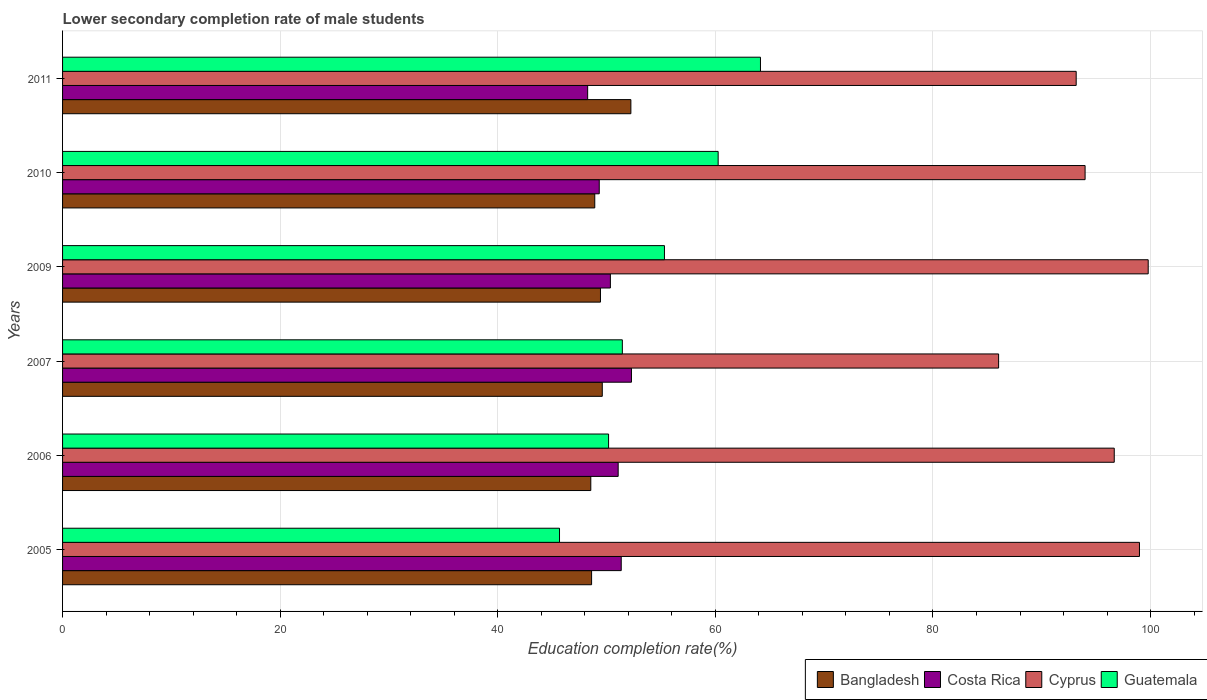How many groups of bars are there?
Your answer should be compact. 6. Are the number of bars on each tick of the Y-axis equal?
Your answer should be very brief. Yes. How many bars are there on the 5th tick from the bottom?
Your response must be concise. 4. What is the lower secondary completion rate of male students in Costa Rica in 2011?
Keep it short and to the point. 48.26. Across all years, what is the maximum lower secondary completion rate of male students in Costa Rica?
Ensure brevity in your answer.  52.29. Across all years, what is the minimum lower secondary completion rate of male students in Costa Rica?
Give a very brief answer. 48.26. What is the total lower secondary completion rate of male students in Cyprus in the graph?
Your answer should be compact. 568.61. What is the difference between the lower secondary completion rate of male students in Cyprus in 2006 and that in 2010?
Provide a succinct answer. 2.68. What is the difference between the lower secondary completion rate of male students in Costa Rica in 2010 and the lower secondary completion rate of male students in Guatemala in 2011?
Provide a short and direct response. -14.82. What is the average lower secondary completion rate of male students in Bangladesh per year?
Offer a very short reply. 49.56. In the year 2010, what is the difference between the lower secondary completion rate of male students in Guatemala and lower secondary completion rate of male students in Bangladesh?
Ensure brevity in your answer.  11.34. In how many years, is the lower secondary completion rate of male students in Guatemala greater than 24 %?
Provide a short and direct response. 6. What is the ratio of the lower secondary completion rate of male students in Costa Rica in 2005 to that in 2011?
Your answer should be compact. 1.06. What is the difference between the highest and the second highest lower secondary completion rate of male students in Cyprus?
Offer a very short reply. 0.8. What is the difference between the highest and the lowest lower secondary completion rate of male students in Guatemala?
Provide a succinct answer. 18.47. Is it the case that in every year, the sum of the lower secondary completion rate of male students in Bangladesh and lower secondary completion rate of male students in Guatemala is greater than the sum of lower secondary completion rate of male students in Costa Rica and lower secondary completion rate of male students in Cyprus?
Your answer should be very brief. No. What does the 1st bar from the top in 2007 represents?
Give a very brief answer. Guatemala. What does the 4th bar from the bottom in 2005 represents?
Provide a succinct answer. Guatemala. Is it the case that in every year, the sum of the lower secondary completion rate of male students in Cyprus and lower secondary completion rate of male students in Costa Rica is greater than the lower secondary completion rate of male students in Bangladesh?
Keep it short and to the point. Yes. Are all the bars in the graph horizontal?
Provide a short and direct response. Yes. How many years are there in the graph?
Offer a very short reply. 6. What is the difference between two consecutive major ticks on the X-axis?
Give a very brief answer. 20. Are the values on the major ticks of X-axis written in scientific E-notation?
Keep it short and to the point. No. Where does the legend appear in the graph?
Your answer should be very brief. Bottom right. How are the legend labels stacked?
Offer a very short reply. Horizontal. What is the title of the graph?
Keep it short and to the point. Lower secondary completion rate of male students. What is the label or title of the X-axis?
Offer a terse response. Education completion rate(%). What is the label or title of the Y-axis?
Keep it short and to the point. Years. What is the Education completion rate(%) of Bangladesh in 2005?
Keep it short and to the point. 48.62. What is the Education completion rate(%) in Costa Rica in 2005?
Keep it short and to the point. 51.35. What is the Education completion rate(%) of Cyprus in 2005?
Provide a succinct answer. 98.98. What is the Education completion rate(%) of Guatemala in 2005?
Make the answer very short. 45.68. What is the Education completion rate(%) of Bangladesh in 2006?
Your answer should be very brief. 48.55. What is the Education completion rate(%) of Costa Rica in 2006?
Your answer should be compact. 51.07. What is the Education completion rate(%) of Cyprus in 2006?
Your answer should be very brief. 96.66. What is the Education completion rate(%) in Guatemala in 2006?
Give a very brief answer. 50.18. What is the Education completion rate(%) of Bangladesh in 2007?
Provide a succinct answer. 49.61. What is the Education completion rate(%) of Costa Rica in 2007?
Your answer should be compact. 52.29. What is the Education completion rate(%) of Cyprus in 2007?
Your answer should be compact. 86.03. What is the Education completion rate(%) of Guatemala in 2007?
Make the answer very short. 51.45. What is the Education completion rate(%) of Bangladesh in 2009?
Your answer should be very brief. 49.44. What is the Education completion rate(%) in Costa Rica in 2009?
Ensure brevity in your answer.  50.35. What is the Education completion rate(%) in Cyprus in 2009?
Make the answer very short. 99.78. What is the Education completion rate(%) of Guatemala in 2009?
Your response must be concise. 55.32. What is the Education completion rate(%) in Bangladesh in 2010?
Provide a short and direct response. 48.92. What is the Education completion rate(%) of Costa Rica in 2010?
Provide a short and direct response. 49.33. What is the Education completion rate(%) in Cyprus in 2010?
Your answer should be very brief. 93.98. What is the Education completion rate(%) in Guatemala in 2010?
Offer a terse response. 60.26. What is the Education completion rate(%) of Bangladesh in 2011?
Offer a terse response. 52.23. What is the Education completion rate(%) in Costa Rica in 2011?
Ensure brevity in your answer.  48.26. What is the Education completion rate(%) of Cyprus in 2011?
Offer a very short reply. 93.16. What is the Education completion rate(%) in Guatemala in 2011?
Ensure brevity in your answer.  64.15. Across all years, what is the maximum Education completion rate(%) in Bangladesh?
Provide a succinct answer. 52.23. Across all years, what is the maximum Education completion rate(%) of Costa Rica?
Your answer should be very brief. 52.29. Across all years, what is the maximum Education completion rate(%) of Cyprus?
Make the answer very short. 99.78. Across all years, what is the maximum Education completion rate(%) of Guatemala?
Give a very brief answer. 64.15. Across all years, what is the minimum Education completion rate(%) of Bangladesh?
Provide a short and direct response. 48.55. Across all years, what is the minimum Education completion rate(%) of Costa Rica?
Keep it short and to the point. 48.26. Across all years, what is the minimum Education completion rate(%) in Cyprus?
Ensure brevity in your answer.  86.03. Across all years, what is the minimum Education completion rate(%) of Guatemala?
Give a very brief answer. 45.68. What is the total Education completion rate(%) of Bangladesh in the graph?
Your answer should be compact. 297.37. What is the total Education completion rate(%) of Costa Rica in the graph?
Offer a very short reply. 302.64. What is the total Education completion rate(%) of Cyprus in the graph?
Keep it short and to the point. 568.61. What is the total Education completion rate(%) in Guatemala in the graph?
Your answer should be compact. 327.03. What is the difference between the Education completion rate(%) in Bangladesh in 2005 and that in 2006?
Provide a succinct answer. 0.07. What is the difference between the Education completion rate(%) in Costa Rica in 2005 and that in 2006?
Ensure brevity in your answer.  0.28. What is the difference between the Education completion rate(%) in Cyprus in 2005 and that in 2006?
Your answer should be compact. 2.32. What is the difference between the Education completion rate(%) of Guatemala in 2005 and that in 2006?
Offer a terse response. -4.51. What is the difference between the Education completion rate(%) in Bangladesh in 2005 and that in 2007?
Provide a short and direct response. -0.98. What is the difference between the Education completion rate(%) in Costa Rica in 2005 and that in 2007?
Offer a very short reply. -0.94. What is the difference between the Education completion rate(%) of Cyprus in 2005 and that in 2007?
Keep it short and to the point. 12.95. What is the difference between the Education completion rate(%) of Guatemala in 2005 and that in 2007?
Offer a very short reply. -5.77. What is the difference between the Education completion rate(%) of Bangladesh in 2005 and that in 2009?
Offer a very short reply. -0.82. What is the difference between the Education completion rate(%) in Cyprus in 2005 and that in 2009?
Your answer should be very brief. -0.8. What is the difference between the Education completion rate(%) of Guatemala in 2005 and that in 2009?
Your response must be concise. -9.64. What is the difference between the Education completion rate(%) of Bangladesh in 2005 and that in 2010?
Your answer should be very brief. -0.29. What is the difference between the Education completion rate(%) of Costa Rica in 2005 and that in 2010?
Give a very brief answer. 2.02. What is the difference between the Education completion rate(%) of Cyprus in 2005 and that in 2010?
Give a very brief answer. 5. What is the difference between the Education completion rate(%) of Guatemala in 2005 and that in 2010?
Keep it short and to the point. -14.58. What is the difference between the Education completion rate(%) in Bangladesh in 2005 and that in 2011?
Give a very brief answer. -3.61. What is the difference between the Education completion rate(%) of Costa Rica in 2005 and that in 2011?
Offer a terse response. 3.09. What is the difference between the Education completion rate(%) in Cyprus in 2005 and that in 2011?
Your answer should be very brief. 5.82. What is the difference between the Education completion rate(%) of Guatemala in 2005 and that in 2011?
Your answer should be very brief. -18.47. What is the difference between the Education completion rate(%) in Bangladesh in 2006 and that in 2007?
Provide a short and direct response. -1.06. What is the difference between the Education completion rate(%) of Costa Rica in 2006 and that in 2007?
Your response must be concise. -1.22. What is the difference between the Education completion rate(%) in Cyprus in 2006 and that in 2007?
Provide a short and direct response. 10.63. What is the difference between the Education completion rate(%) of Guatemala in 2006 and that in 2007?
Your answer should be compact. -1.26. What is the difference between the Education completion rate(%) of Bangladesh in 2006 and that in 2009?
Your answer should be compact. -0.89. What is the difference between the Education completion rate(%) in Costa Rica in 2006 and that in 2009?
Give a very brief answer. 0.71. What is the difference between the Education completion rate(%) in Cyprus in 2006 and that in 2009?
Offer a terse response. -3.12. What is the difference between the Education completion rate(%) of Guatemala in 2006 and that in 2009?
Your answer should be compact. -5.14. What is the difference between the Education completion rate(%) of Bangladesh in 2006 and that in 2010?
Offer a very short reply. -0.36. What is the difference between the Education completion rate(%) of Costa Rica in 2006 and that in 2010?
Keep it short and to the point. 1.74. What is the difference between the Education completion rate(%) of Cyprus in 2006 and that in 2010?
Your answer should be compact. 2.68. What is the difference between the Education completion rate(%) in Guatemala in 2006 and that in 2010?
Make the answer very short. -10.07. What is the difference between the Education completion rate(%) in Bangladesh in 2006 and that in 2011?
Ensure brevity in your answer.  -3.68. What is the difference between the Education completion rate(%) of Costa Rica in 2006 and that in 2011?
Provide a short and direct response. 2.8. What is the difference between the Education completion rate(%) in Cyprus in 2006 and that in 2011?
Your answer should be very brief. 3.5. What is the difference between the Education completion rate(%) of Guatemala in 2006 and that in 2011?
Keep it short and to the point. -13.96. What is the difference between the Education completion rate(%) of Bangladesh in 2007 and that in 2009?
Your answer should be very brief. 0.17. What is the difference between the Education completion rate(%) in Costa Rica in 2007 and that in 2009?
Your response must be concise. 1.94. What is the difference between the Education completion rate(%) in Cyprus in 2007 and that in 2009?
Give a very brief answer. -13.75. What is the difference between the Education completion rate(%) of Guatemala in 2007 and that in 2009?
Your response must be concise. -3.87. What is the difference between the Education completion rate(%) in Bangladesh in 2007 and that in 2010?
Your answer should be compact. 0.69. What is the difference between the Education completion rate(%) of Costa Rica in 2007 and that in 2010?
Provide a succinct answer. 2.96. What is the difference between the Education completion rate(%) in Cyprus in 2007 and that in 2010?
Keep it short and to the point. -7.95. What is the difference between the Education completion rate(%) of Guatemala in 2007 and that in 2010?
Your response must be concise. -8.81. What is the difference between the Education completion rate(%) of Bangladesh in 2007 and that in 2011?
Keep it short and to the point. -2.63. What is the difference between the Education completion rate(%) in Costa Rica in 2007 and that in 2011?
Make the answer very short. 4.03. What is the difference between the Education completion rate(%) in Cyprus in 2007 and that in 2011?
Offer a terse response. -7.13. What is the difference between the Education completion rate(%) in Guatemala in 2007 and that in 2011?
Make the answer very short. -12.7. What is the difference between the Education completion rate(%) in Bangladesh in 2009 and that in 2010?
Give a very brief answer. 0.52. What is the difference between the Education completion rate(%) of Costa Rica in 2009 and that in 2010?
Your answer should be very brief. 1.02. What is the difference between the Education completion rate(%) in Cyprus in 2009 and that in 2010?
Make the answer very short. 5.8. What is the difference between the Education completion rate(%) of Guatemala in 2009 and that in 2010?
Your response must be concise. -4.94. What is the difference between the Education completion rate(%) in Bangladesh in 2009 and that in 2011?
Make the answer very short. -2.8. What is the difference between the Education completion rate(%) of Costa Rica in 2009 and that in 2011?
Provide a succinct answer. 2.09. What is the difference between the Education completion rate(%) in Cyprus in 2009 and that in 2011?
Provide a succinct answer. 6.62. What is the difference between the Education completion rate(%) in Guatemala in 2009 and that in 2011?
Your answer should be compact. -8.82. What is the difference between the Education completion rate(%) in Bangladesh in 2010 and that in 2011?
Keep it short and to the point. -3.32. What is the difference between the Education completion rate(%) of Costa Rica in 2010 and that in 2011?
Your response must be concise. 1.07. What is the difference between the Education completion rate(%) in Cyprus in 2010 and that in 2011?
Your answer should be very brief. 0.82. What is the difference between the Education completion rate(%) of Guatemala in 2010 and that in 2011?
Provide a succinct answer. -3.89. What is the difference between the Education completion rate(%) in Bangladesh in 2005 and the Education completion rate(%) in Costa Rica in 2006?
Offer a terse response. -2.44. What is the difference between the Education completion rate(%) in Bangladesh in 2005 and the Education completion rate(%) in Cyprus in 2006?
Your answer should be compact. -48.04. What is the difference between the Education completion rate(%) in Bangladesh in 2005 and the Education completion rate(%) in Guatemala in 2006?
Your answer should be compact. -1.56. What is the difference between the Education completion rate(%) in Costa Rica in 2005 and the Education completion rate(%) in Cyprus in 2006?
Offer a terse response. -45.31. What is the difference between the Education completion rate(%) in Costa Rica in 2005 and the Education completion rate(%) in Guatemala in 2006?
Make the answer very short. 1.16. What is the difference between the Education completion rate(%) of Cyprus in 2005 and the Education completion rate(%) of Guatemala in 2006?
Make the answer very short. 48.8. What is the difference between the Education completion rate(%) in Bangladesh in 2005 and the Education completion rate(%) in Costa Rica in 2007?
Your answer should be very brief. -3.66. What is the difference between the Education completion rate(%) of Bangladesh in 2005 and the Education completion rate(%) of Cyprus in 2007?
Make the answer very short. -37.41. What is the difference between the Education completion rate(%) of Bangladesh in 2005 and the Education completion rate(%) of Guatemala in 2007?
Provide a succinct answer. -2.83. What is the difference between the Education completion rate(%) of Costa Rica in 2005 and the Education completion rate(%) of Cyprus in 2007?
Ensure brevity in your answer.  -34.69. What is the difference between the Education completion rate(%) in Costa Rica in 2005 and the Education completion rate(%) in Guatemala in 2007?
Provide a succinct answer. -0.1. What is the difference between the Education completion rate(%) of Cyprus in 2005 and the Education completion rate(%) of Guatemala in 2007?
Your response must be concise. 47.53. What is the difference between the Education completion rate(%) of Bangladesh in 2005 and the Education completion rate(%) of Costa Rica in 2009?
Provide a succinct answer. -1.73. What is the difference between the Education completion rate(%) in Bangladesh in 2005 and the Education completion rate(%) in Cyprus in 2009?
Provide a short and direct response. -51.16. What is the difference between the Education completion rate(%) in Bangladesh in 2005 and the Education completion rate(%) in Guatemala in 2009?
Your answer should be compact. -6.7. What is the difference between the Education completion rate(%) in Costa Rica in 2005 and the Education completion rate(%) in Cyprus in 2009?
Your response must be concise. -48.44. What is the difference between the Education completion rate(%) of Costa Rica in 2005 and the Education completion rate(%) of Guatemala in 2009?
Your answer should be very brief. -3.97. What is the difference between the Education completion rate(%) of Cyprus in 2005 and the Education completion rate(%) of Guatemala in 2009?
Keep it short and to the point. 43.66. What is the difference between the Education completion rate(%) of Bangladesh in 2005 and the Education completion rate(%) of Costa Rica in 2010?
Ensure brevity in your answer.  -0.7. What is the difference between the Education completion rate(%) in Bangladesh in 2005 and the Education completion rate(%) in Cyprus in 2010?
Offer a terse response. -45.36. What is the difference between the Education completion rate(%) of Bangladesh in 2005 and the Education completion rate(%) of Guatemala in 2010?
Offer a terse response. -11.63. What is the difference between the Education completion rate(%) in Costa Rica in 2005 and the Education completion rate(%) in Cyprus in 2010?
Make the answer very short. -42.64. What is the difference between the Education completion rate(%) of Costa Rica in 2005 and the Education completion rate(%) of Guatemala in 2010?
Offer a terse response. -8.91. What is the difference between the Education completion rate(%) of Cyprus in 2005 and the Education completion rate(%) of Guatemala in 2010?
Your answer should be very brief. 38.72. What is the difference between the Education completion rate(%) in Bangladesh in 2005 and the Education completion rate(%) in Costa Rica in 2011?
Ensure brevity in your answer.  0.36. What is the difference between the Education completion rate(%) of Bangladesh in 2005 and the Education completion rate(%) of Cyprus in 2011?
Give a very brief answer. -44.54. What is the difference between the Education completion rate(%) of Bangladesh in 2005 and the Education completion rate(%) of Guatemala in 2011?
Provide a succinct answer. -15.52. What is the difference between the Education completion rate(%) in Costa Rica in 2005 and the Education completion rate(%) in Cyprus in 2011?
Your answer should be very brief. -41.82. What is the difference between the Education completion rate(%) of Costa Rica in 2005 and the Education completion rate(%) of Guatemala in 2011?
Provide a succinct answer. -12.8. What is the difference between the Education completion rate(%) in Cyprus in 2005 and the Education completion rate(%) in Guatemala in 2011?
Make the answer very short. 34.83. What is the difference between the Education completion rate(%) of Bangladesh in 2006 and the Education completion rate(%) of Costa Rica in 2007?
Your answer should be very brief. -3.74. What is the difference between the Education completion rate(%) of Bangladesh in 2006 and the Education completion rate(%) of Cyprus in 2007?
Offer a terse response. -37.48. What is the difference between the Education completion rate(%) of Bangladesh in 2006 and the Education completion rate(%) of Guatemala in 2007?
Your answer should be very brief. -2.9. What is the difference between the Education completion rate(%) in Costa Rica in 2006 and the Education completion rate(%) in Cyprus in 2007?
Keep it short and to the point. -34.97. What is the difference between the Education completion rate(%) of Costa Rica in 2006 and the Education completion rate(%) of Guatemala in 2007?
Your response must be concise. -0.38. What is the difference between the Education completion rate(%) of Cyprus in 2006 and the Education completion rate(%) of Guatemala in 2007?
Provide a short and direct response. 45.21. What is the difference between the Education completion rate(%) in Bangladesh in 2006 and the Education completion rate(%) in Costa Rica in 2009?
Give a very brief answer. -1.8. What is the difference between the Education completion rate(%) of Bangladesh in 2006 and the Education completion rate(%) of Cyprus in 2009?
Your response must be concise. -51.23. What is the difference between the Education completion rate(%) of Bangladesh in 2006 and the Education completion rate(%) of Guatemala in 2009?
Ensure brevity in your answer.  -6.77. What is the difference between the Education completion rate(%) of Costa Rica in 2006 and the Education completion rate(%) of Cyprus in 2009?
Keep it short and to the point. -48.72. What is the difference between the Education completion rate(%) of Costa Rica in 2006 and the Education completion rate(%) of Guatemala in 2009?
Provide a succinct answer. -4.25. What is the difference between the Education completion rate(%) of Cyprus in 2006 and the Education completion rate(%) of Guatemala in 2009?
Keep it short and to the point. 41.34. What is the difference between the Education completion rate(%) in Bangladesh in 2006 and the Education completion rate(%) in Costa Rica in 2010?
Provide a succinct answer. -0.78. What is the difference between the Education completion rate(%) of Bangladesh in 2006 and the Education completion rate(%) of Cyprus in 2010?
Offer a very short reply. -45.43. What is the difference between the Education completion rate(%) of Bangladesh in 2006 and the Education completion rate(%) of Guatemala in 2010?
Your answer should be compact. -11.71. What is the difference between the Education completion rate(%) of Costa Rica in 2006 and the Education completion rate(%) of Cyprus in 2010?
Give a very brief answer. -42.92. What is the difference between the Education completion rate(%) in Costa Rica in 2006 and the Education completion rate(%) in Guatemala in 2010?
Provide a succinct answer. -9.19. What is the difference between the Education completion rate(%) of Cyprus in 2006 and the Education completion rate(%) of Guatemala in 2010?
Ensure brevity in your answer.  36.41. What is the difference between the Education completion rate(%) of Bangladesh in 2006 and the Education completion rate(%) of Costa Rica in 2011?
Ensure brevity in your answer.  0.29. What is the difference between the Education completion rate(%) in Bangladesh in 2006 and the Education completion rate(%) in Cyprus in 2011?
Give a very brief answer. -44.61. What is the difference between the Education completion rate(%) of Bangladesh in 2006 and the Education completion rate(%) of Guatemala in 2011?
Your response must be concise. -15.6. What is the difference between the Education completion rate(%) in Costa Rica in 2006 and the Education completion rate(%) in Cyprus in 2011?
Provide a succinct answer. -42.1. What is the difference between the Education completion rate(%) of Costa Rica in 2006 and the Education completion rate(%) of Guatemala in 2011?
Provide a short and direct response. -13.08. What is the difference between the Education completion rate(%) in Cyprus in 2006 and the Education completion rate(%) in Guatemala in 2011?
Your answer should be compact. 32.52. What is the difference between the Education completion rate(%) of Bangladesh in 2007 and the Education completion rate(%) of Costa Rica in 2009?
Your answer should be very brief. -0.75. What is the difference between the Education completion rate(%) in Bangladesh in 2007 and the Education completion rate(%) in Cyprus in 2009?
Your response must be concise. -50.18. What is the difference between the Education completion rate(%) of Bangladesh in 2007 and the Education completion rate(%) of Guatemala in 2009?
Your answer should be compact. -5.71. What is the difference between the Education completion rate(%) of Costa Rica in 2007 and the Education completion rate(%) of Cyprus in 2009?
Provide a succinct answer. -47.5. What is the difference between the Education completion rate(%) of Costa Rica in 2007 and the Education completion rate(%) of Guatemala in 2009?
Offer a very short reply. -3.03. What is the difference between the Education completion rate(%) in Cyprus in 2007 and the Education completion rate(%) in Guatemala in 2009?
Offer a terse response. 30.71. What is the difference between the Education completion rate(%) of Bangladesh in 2007 and the Education completion rate(%) of Costa Rica in 2010?
Make the answer very short. 0.28. What is the difference between the Education completion rate(%) of Bangladesh in 2007 and the Education completion rate(%) of Cyprus in 2010?
Your answer should be compact. -44.38. What is the difference between the Education completion rate(%) of Bangladesh in 2007 and the Education completion rate(%) of Guatemala in 2010?
Offer a terse response. -10.65. What is the difference between the Education completion rate(%) in Costa Rica in 2007 and the Education completion rate(%) in Cyprus in 2010?
Your answer should be compact. -41.7. What is the difference between the Education completion rate(%) of Costa Rica in 2007 and the Education completion rate(%) of Guatemala in 2010?
Your response must be concise. -7.97. What is the difference between the Education completion rate(%) in Cyprus in 2007 and the Education completion rate(%) in Guatemala in 2010?
Provide a short and direct response. 25.78. What is the difference between the Education completion rate(%) in Bangladesh in 2007 and the Education completion rate(%) in Costa Rica in 2011?
Provide a short and direct response. 1.34. What is the difference between the Education completion rate(%) in Bangladesh in 2007 and the Education completion rate(%) in Cyprus in 2011?
Your response must be concise. -43.56. What is the difference between the Education completion rate(%) of Bangladesh in 2007 and the Education completion rate(%) of Guatemala in 2011?
Keep it short and to the point. -14.54. What is the difference between the Education completion rate(%) in Costa Rica in 2007 and the Education completion rate(%) in Cyprus in 2011?
Offer a terse response. -40.88. What is the difference between the Education completion rate(%) of Costa Rica in 2007 and the Education completion rate(%) of Guatemala in 2011?
Your answer should be very brief. -11.86. What is the difference between the Education completion rate(%) in Cyprus in 2007 and the Education completion rate(%) in Guatemala in 2011?
Your response must be concise. 21.89. What is the difference between the Education completion rate(%) in Bangladesh in 2009 and the Education completion rate(%) in Costa Rica in 2010?
Give a very brief answer. 0.11. What is the difference between the Education completion rate(%) of Bangladesh in 2009 and the Education completion rate(%) of Cyprus in 2010?
Keep it short and to the point. -44.54. What is the difference between the Education completion rate(%) in Bangladesh in 2009 and the Education completion rate(%) in Guatemala in 2010?
Your response must be concise. -10.82. What is the difference between the Education completion rate(%) in Costa Rica in 2009 and the Education completion rate(%) in Cyprus in 2010?
Offer a terse response. -43.63. What is the difference between the Education completion rate(%) in Costa Rica in 2009 and the Education completion rate(%) in Guatemala in 2010?
Offer a very short reply. -9.9. What is the difference between the Education completion rate(%) in Cyprus in 2009 and the Education completion rate(%) in Guatemala in 2010?
Your answer should be very brief. 39.53. What is the difference between the Education completion rate(%) in Bangladesh in 2009 and the Education completion rate(%) in Costa Rica in 2011?
Give a very brief answer. 1.18. What is the difference between the Education completion rate(%) in Bangladesh in 2009 and the Education completion rate(%) in Cyprus in 2011?
Provide a short and direct response. -43.72. What is the difference between the Education completion rate(%) in Bangladesh in 2009 and the Education completion rate(%) in Guatemala in 2011?
Offer a very short reply. -14.71. What is the difference between the Education completion rate(%) of Costa Rica in 2009 and the Education completion rate(%) of Cyprus in 2011?
Provide a succinct answer. -42.81. What is the difference between the Education completion rate(%) in Costa Rica in 2009 and the Education completion rate(%) in Guatemala in 2011?
Give a very brief answer. -13.79. What is the difference between the Education completion rate(%) in Cyprus in 2009 and the Education completion rate(%) in Guatemala in 2011?
Ensure brevity in your answer.  35.64. What is the difference between the Education completion rate(%) in Bangladesh in 2010 and the Education completion rate(%) in Costa Rica in 2011?
Ensure brevity in your answer.  0.65. What is the difference between the Education completion rate(%) of Bangladesh in 2010 and the Education completion rate(%) of Cyprus in 2011?
Your response must be concise. -44.25. What is the difference between the Education completion rate(%) in Bangladesh in 2010 and the Education completion rate(%) in Guatemala in 2011?
Keep it short and to the point. -15.23. What is the difference between the Education completion rate(%) of Costa Rica in 2010 and the Education completion rate(%) of Cyprus in 2011?
Make the answer very short. -43.84. What is the difference between the Education completion rate(%) of Costa Rica in 2010 and the Education completion rate(%) of Guatemala in 2011?
Offer a very short reply. -14.82. What is the difference between the Education completion rate(%) of Cyprus in 2010 and the Education completion rate(%) of Guatemala in 2011?
Make the answer very short. 29.84. What is the average Education completion rate(%) in Bangladesh per year?
Provide a succinct answer. 49.56. What is the average Education completion rate(%) of Costa Rica per year?
Your answer should be very brief. 50.44. What is the average Education completion rate(%) of Cyprus per year?
Your answer should be very brief. 94.77. What is the average Education completion rate(%) in Guatemala per year?
Your answer should be compact. 54.51. In the year 2005, what is the difference between the Education completion rate(%) in Bangladesh and Education completion rate(%) in Costa Rica?
Make the answer very short. -2.72. In the year 2005, what is the difference between the Education completion rate(%) in Bangladesh and Education completion rate(%) in Cyprus?
Your answer should be very brief. -50.36. In the year 2005, what is the difference between the Education completion rate(%) in Bangladesh and Education completion rate(%) in Guatemala?
Your response must be concise. 2.95. In the year 2005, what is the difference between the Education completion rate(%) in Costa Rica and Education completion rate(%) in Cyprus?
Your answer should be very brief. -47.63. In the year 2005, what is the difference between the Education completion rate(%) of Costa Rica and Education completion rate(%) of Guatemala?
Your answer should be very brief. 5.67. In the year 2005, what is the difference between the Education completion rate(%) in Cyprus and Education completion rate(%) in Guatemala?
Offer a terse response. 53.3. In the year 2006, what is the difference between the Education completion rate(%) in Bangladesh and Education completion rate(%) in Costa Rica?
Give a very brief answer. -2.52. In the year 2006, what is the difference between the Education completion rate(%) in Bangladesh and Education completion rate(%) in Cyprus?
Ensure brevity in your answer.  -48.11. In the year 2006, what is the difference between the Education completion rate(%) in Bangladesh and Education completion rate(%) in Guatemala?
Ensure brevity in your answer.  -1.63. In the year 2006, what is the difference between the Education completion rate(%) in Costa Rica and Education completion rate(%) in Cyprus?
Make the answer very short. -45.6. In the year 2006, what is the difference between the Education completion rate(%) of Costa Rica and Education completion rate(%) of Guatemala?
Give a very brief answer. 0.88. In the year 2006, what is the difference between the Education completion rate(%) of Cyprus and Education completion rate(%) of Guatemala?
Keep it short and to the point. 46.48. In the year 2007, what is the difference between the Education completion rate(%) in Bangladesh and Education completion rate(%) in Costa Rica?
Offer a very short reply. -2.68. In the year 2007, what is the difference between the Education completion rate(%) of Bangladesh and Education completion rate(%) of Cyprus?
Provide a short and direct response. -36.43. In the year 2007, what is the difference between the Education completion rate(%) in Bangladesh and Education completion rate(%) in Guatemala?
Provide a short and direct response. -1.84. In the year 2007, what is the difference between the Education completion rate(%) of Costa Rica and Education completion rate(%) of Cyprus?
Make the answer very short. -33.75. In the year 2007, what is the difference between the Education completion rate(%) of Costa Rica and Education completion rate(%) of Guatemala?
Ensure brevity in your answer.  0.84. In the year 2007, what is the difference between the Education completion rate(%) in Cyprus and Education completion rate(%) in Guatemala?
Make the answer very short. 34.58. In the year 2009, what is the difference between the Education completion rate(%) of Bangladesh and Education completion rate(%) of Costa Rica?
Keep it short and to the point. -0.91. In the year 2009, what is the difference between the Education completion rate(%) in Bangladesh and Education completion rate(%) in Cyprus?
Offer a very short reply. -50.34. In the year 2009, what is the difference between the Education completion rate(%) in Bangladesh and Education completion rate(%) in Guatemala?
Provide a succinct answer. -5.88. In the year 2009, what is the difference between the Education completion rate(%) of Costa Rica and Education completion rate(%) of Cyprus?
Offer a terse response. -49.43. In the year 2009, what is the difference between the Education completion rate(%) in Costa Rica and Education completion rate(%) in Guatemala?
Keep it short and to the point. -4.97. In the year 2009, what is the difference between the Education completion rate(%) in Cyprus and Education completion rate(%) in Guatemala?
Your answer should be very brief. 44.46. In the year 2010, what is the difference between the Education completion rate(%) in Bangladesh and Education completion rate(%) in Costa Rica?
Offer a very short reply. -0.41. In the year 2010, what is the difference between the Education completion rate(%) in Bangladesh and Education completion rate(%) in Cyprus?
Your response must be concise. -45.07. In the year 2010, what is the difference between the Education completion rate(%) of Bangladesh and Education completion rate(%) of Guatemala?
Offer a very short reply. -11.34. In the year 2010, what is the difference between the Education completion rate(%) of Costa Rica and Education completion rate(%) of Cyprus?
Provide a succinct answer. -44.65. In the year 2010, what is the difference between the Education completion rate(%) of Costa Rica and Education completion rate(%) of Guatemala?
Your response must be concise. -10.93. In the year 2010, what is the difference between the Education completion rate(%) of Cyprus and Education completion rate(%) of Guatemala?
Your answer should be compact. 33.73. In the year 2011, what is the difference between the Education completion rate(%) of Bangladesh and Education completion rate(%) of Costa Rica?
Your answer should be very brief. 3.97. In the year 2011, what is the difference between the Education completion rate(%) in Bangladesh and Education completion rate(%) in Cyprus?
Give a very brief answer. -40.93. In the year 2011, what is the difference between the Education completion rate(%) in Bangladesh and Education completion rate(%) in Guatemala?
Keep it short and to the point. -11.91. In the year 2011, what is the difference between the Education completion rate(%) of Costa Rica and Education completion rate(%) of Cyprus?
Your answer should be very brief. -44.9. In the year 2011, what is the difference between the Education completion rate(%) in Costa Rica and Education completion rate(%) in Guatemala?
Your response must be concise. -15.88. In the year 2011, what is the difference between the Education completion rate(%) in Cyprus and Education completion rate(%) in Guatemala?
Provide a succinct answer. 29.02. What is the ratio of the Education completion rate(%) of Bangladesh in 2005 to that in 2006?
Offer a very short reply. 1. What is the ratio of the Education completion rate(%) of Costa Rica in 2005 to that in 2006?
Ensure brevity in your answer.  1.01. What is the ratio of the Education completion rate(%) of Cyprus in 2005 to that in 2006?
Provide a succinct answer. 1.02. What is the ratio of the Education completion rate(%) in Guatemala in 2005 to that in 2006?
Provide a short and direct response. 0.91. What is the ratio of the Education completion rate(%) in Bangladesh in 2005 to that in 2007?
Your response must be concise. 0.98. What is the ratio of the Education completion rate(%) in Cyprus in 2005 to that in 2007?
Provide a succinct answer. 1.15. What is the ratio of the Education completion rate(%) in Guatemala in 2005 to that in 2007?
Ensure brevity in your answer.  0.89. What is the ratio of the Education completion rate(%) in Bangladesh in 2005 to that in 2009?
Provide a short and direct response. 0.98. What is the ratio of the Education completion rate(%) of Costa Rica in 2005 to that in 2009?
Keep it short and to the point. 1.02. What is the ratio of the Education completion rate(%) in Cyprus in 2005 to that in 2009?
Provide a succinct answer. 0.99. What is the ratio of the Education completion rate(%) of Guatemala in 2005 to that in 2009?
Ensure brevity in your answer.  0.83. What is the ratio of the Education completion rate(%) of Bangladesh in 2005 to that in 2010?
Offer a very short reply. 0.99. What is the ratio of the Education completion rate(%) in Costa Rica in 2005 to that in 2010?
Ensure brevity in your answer.  1.04. What is the ratio of the Education completion rate(%) in Cyprus in 2005 to that in 2010?
Your response must be concise. 1.05. What is the ratio of the Education completion rate(%) of Guatemala in 2005 to that in 2010?
Ensure brevity in your answer.  0.76. What is the ratio of the Education completion rate(%) of Bangladesh in 2005 to that in 2011?
Offer a terse response. 0.93. What is the ratio of the Education completion rate(%) in Costa Rica in 2005 to that in 2011?
Your answer should be very brief. 1.06. What is the ratio of the Education completion rate(%) in Cyprus in 2005 to that in 2011?
Provide a short and direct response. 1.06. What is the ratio of the Education completion rate(%) in Guatemala in 2005 to that in 2011?
Make the answer very short. 0.71. What is the ratio of the Education completion rate(%) in Bangladesh in 2006 to that in 2007?
Make the answer very short. 0.98. What is the ratio of the Education completion rate(%) of Costa Rica in 2006 to that in 2007?
Offer a terse response. 0.98. What is the ratio of the Education completion rate(%) of Cyprus in 2006 to that in 2007?
Keep it short and to the point. 1.12. What is the ratio of the Education completion rate(%) of Guatemala in 2006 to that in 2007?
Offer a terse response. 0.98. What is the ratio of the Education completion rate(%) in Bangladesh in 2006 to that in 2009?
Offer a very short reply. 0.98. What is the ratio of the Education completion rate(%) of Costa Rica in 2006 to that in 2009?
Make the answer very short. 1.01. What is the ratio of the Education completion rate(%) of Cyprus in 2006 to that in 2009?
Provide a short and direct response. 0.97. What is the ratio of the Education completion rate(%) in Guatemala in 2006 to that in 2009?
Keep it short and to the point. 0.91. What is the ratio of the Education completion rate(%) in Costa Rica in 2006 to that in 2010?
Make the answer very short. 1.04. What is the ratio of the Education completion rate(%) in Cyprus in 2006 to that in 2010?
Your answer should be compact. 1.03. What is the ratio of the Education completion rate(%) in Guatemala in 2006 to that in 2010?
Offer a terse response. 0.83. What is the ratio of the Education completion rate(%) of Bangladesh in 2006 to that in 2011?
Provide a succinct answer. 0.93. What is the ratio of the Education completion rate(%) in Costa Rica in 2006 to that in 2011?
Ensure brevity in your answer.  1.06. What is the ratio of the Education completion rate(%) of Cyprus in 2006 to that in 2011?
Give a very brief answer. 1.04. What is the ratio of the Education completion rate(%) of Guatemala in 2006 to that in 2011?
Make the answer very short. 0.78. What is the ratio of the Education completion rate(%) of Costa Rica in 2007 to that in 2009?
Keep it short and to the point. 1.04. What is the ratio of the Education completion rate(%) in Cyprus in 2007 to that in 2009?
Give a very brief answer. 0.86. What is the ratio of the Education completion rate(%) of Bangladesh in 2007 to that in 2010?
Ensure brevity in your answer.  1.01. What is the ratio of the Education completion rate(%) of Costa Rica in 2007 to that in 2010?
Offer a terse response. 1.06. What is the ratio of the Education completion rate(%) in Cyprus in 2007 to that in 2010?
Ensure brevity in your answer.  0.92. What is the ratio of the Education completion rate(%) in Guatemala in 2007 to that in 2010?
Give a very brief answer. 0.85. What is the ratio of the Education completion rate(%) of Bangladesh in 2007 to that in 2011?
Your answer should be very brief. 0.95. What is the ratio of the Education completion rate(%) in Costa Rica in 2007 to that in 2011?
Your answer should be very brief. 1.08. What is the ratio of the Education completion rate(%) in Cyprus in 2007 to that in 2011?
Your answer should be compact. 0.92. What is the ratio of the Education completion rate(%) in Guatemala in 2007 to that in 2011?
Ensure brevity in your answer.  0.8. What is the ratio of the Education completion rate(%) of Bangladesh in 2009 to that in 2010?
Provide a short and direct response. 1.01. What is the ratio of the Education completion rate(%) in Costa Rica in 2009 to that in 2010?
Provide a succinct answer. 1.02. What is the ratio of the Education completion rate(%) of Cyprus in 2009 to that in 2010?
Your response must be concise. 1.06. What is the ratio of the Education completion rate(%) in Guatemala in 2009 to that in 2010?
Keep it short and to the point. 0.92. What is the ratio of the Education completion rate(%) in Bangladesh in 2009 to that in 2011?
Provide a short and direct response. 0.95. What is the ratio of the Education completion rate(%) of Costa Rica in 2009 to that in 2011?
Give a very brief answer. 1.04. What is the ratio of the Education completion rate(%) of Cyprus in 2009 to that in 2011?
Ensure brevity in your answer.  1.07. What is the ratio of the Education completion rate(%) in Guatemala in 2009 to that in 2011?
Your response must be concise. 0.86. What is the ratio of the Education completion rate(%) in Bangladesh in 2010 to that in 2011?
Make the answer very short. 0.94. What is the ratio of the Education completion rate(%) in Costa Rica in 2010 to that in 2011?
Offer a terse response. 1.02. What is the ratio of the Education completion rate(%) in Cyprus in 2010 to that in 2011?
Your answer should be compact. 1.01. What is the ratio of the Education completion rate(%) in Guatemala in 2010 to that in 2011?
Your answer should be very brief. 0.94. What is the difference between the highest and the second highest Education completion rate(%) of Bangladesh?
Make the answer very short. 2.63. What is the difference between the highest and the second highest Education completion rate(%) of Costa Rica?
Make the answer very short. 0.94. What is the difference between the highest and the second highest Education completion rate(%) of Cyprus?
Offer a very short reply. 0.8. What is the difference between the highest and the second highest Education completion rate(%) in Guatemala?
Keep it short and to the point. 3.89. What is the difference between the highest and the lowest Education completion rate(%) in Bangladesh?
Make the answer very short. 3.68. What is the difference between the highest and the lowest Education completion rate(%) of Costa Rica?
Ensure brevity in your answer.  4.03. What is the difference between the highest and the lowest Education completion rate(%) in Cyprus?
Ensure brevity in your answer.  13.75. What is the difference between the highest and the lowest Education completion rate(%) in Guatemala?
Make the answer very short. 18.47. 